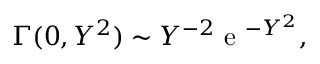<formula> <loc_0><loc_0><loc_500><loc_500>\Gamma ( 0 , Y ^ { 2 } ) \sim Y ^ { - 2 } e ^ { - Y ^ { 2 } } ,</formula> 